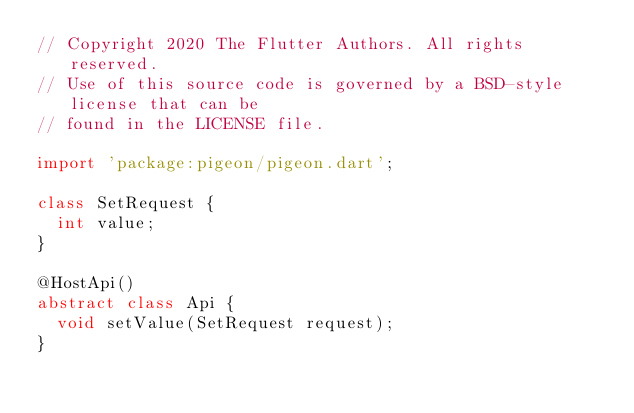Convert code to text. <code><loc_0><loc_0><loc_500><loc_500><_Dart_>// Copyright 2020 The Flutter Authors. All rights reserved.
// Use of this source code is governed by a BSD-style license that can be
// found in the LICENSE file.

import 'package:pigeon/pigeon.dart';

class SetRequest {
  int value;
}

@HostApi()
abstract class Api {
  void setValue(SetRequest request);
}
</code> 